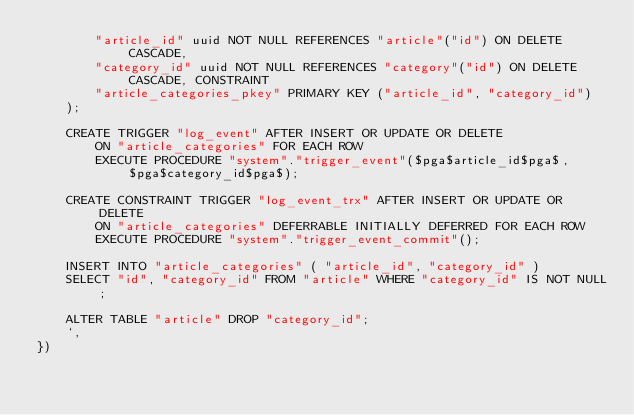<code> <loc_0><loc_0><loc_500><loc_500><_TypeScript_>		"article_id" uuid NOT NULL REFERENCES "article"("id") ON DELETE CASCADE,
		"category_id" uuid NOT NULL REFERENCES "category"("id") ON DELETE CASCADE, CONSTRAINT
		"article_categories_pkey" PRIMARY KEY ("article_id", "category_id")
	);

	CREATE TRIGGER "log_event" AFTER INSERT OR UPDATE OR DELETE
	    ON "article_categories" FOR EACH ROW
	    EXECUTE PROCEDURE "system"."trigger_event"($pga$article_id$pga$, $pga$category_id$pga$);

	CREATE CONSTRAINT TRIGGER "log_event_trx" AFTER INSERT OR UPDATE OR DELETE
	    ON "article_categories" DEFERRABLE INITIALLY DEFERRED FOR EACH ROW
	    EXECUTE PROCEDURE "system"."trigger_event_commit"();

	INSERT INTO "article_categories" ( "article_id", "category_id" )
	SELECT "id", "category_id" FROM "article" WHERE "category_id" IS NOT NULL;

	ALTER TABLE "article" DROP "category_id";
	`,
})
</code> 